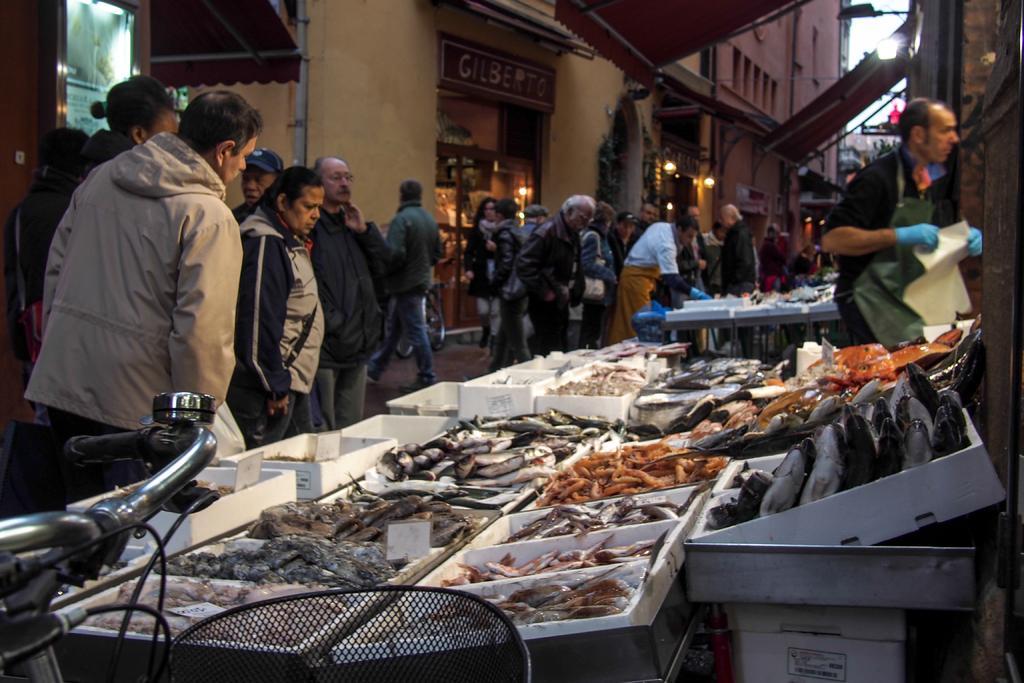How would you summarize this image in a sentence or two? In this image there are few group of people , buildings, there are some lights visible, at the bottom there is a bi-cycle, in the foreground there are few boxes on which there are few fishes, on the right side there is a person holding a paper. 